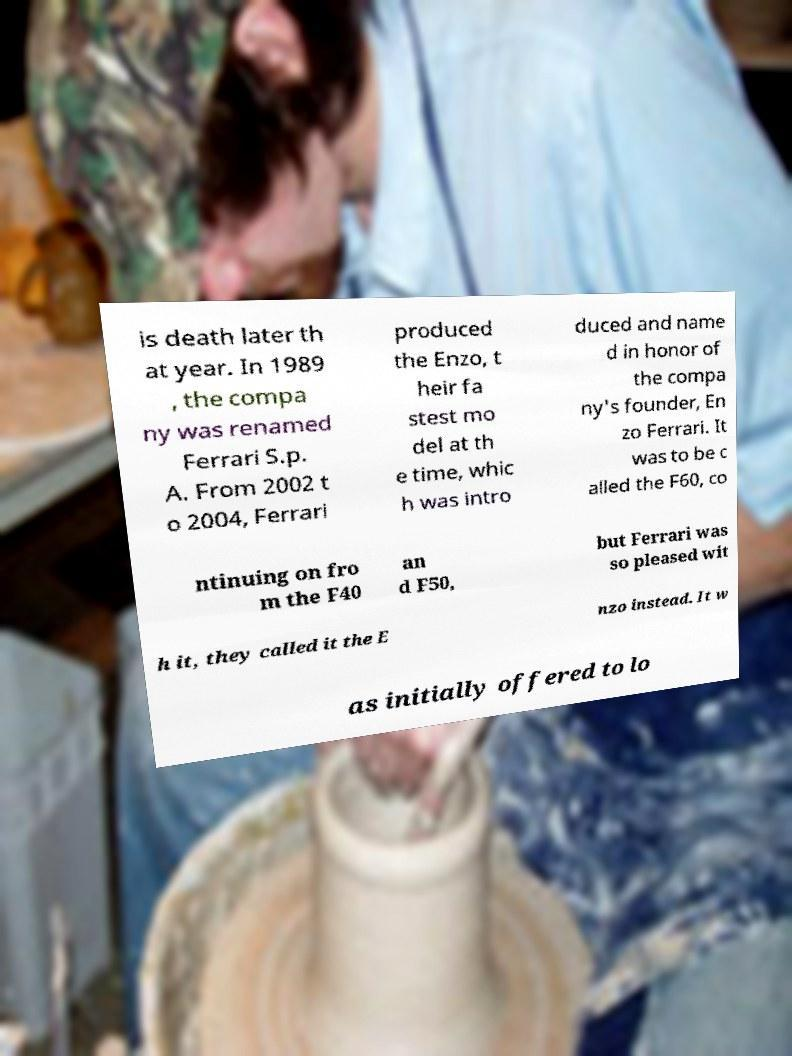I need the written content from this picture converted into text. Can you do that? is death later th at year. In 1989 , the compa ny was renamed Ferrari S.p. A. From 2002 t o 2004, Ferrari produced the Enzo, t heir fa stest mo del at th e time, whic h was intro duced and name d in honor of the compa ny's founder, En zo Ferrari. It was to be c alled the F60, co ntinuing on fro m the F40 an d F50, but Ferrari was so pleased wit h it, they called it the E nzo instead. It w as initially offered to lo 